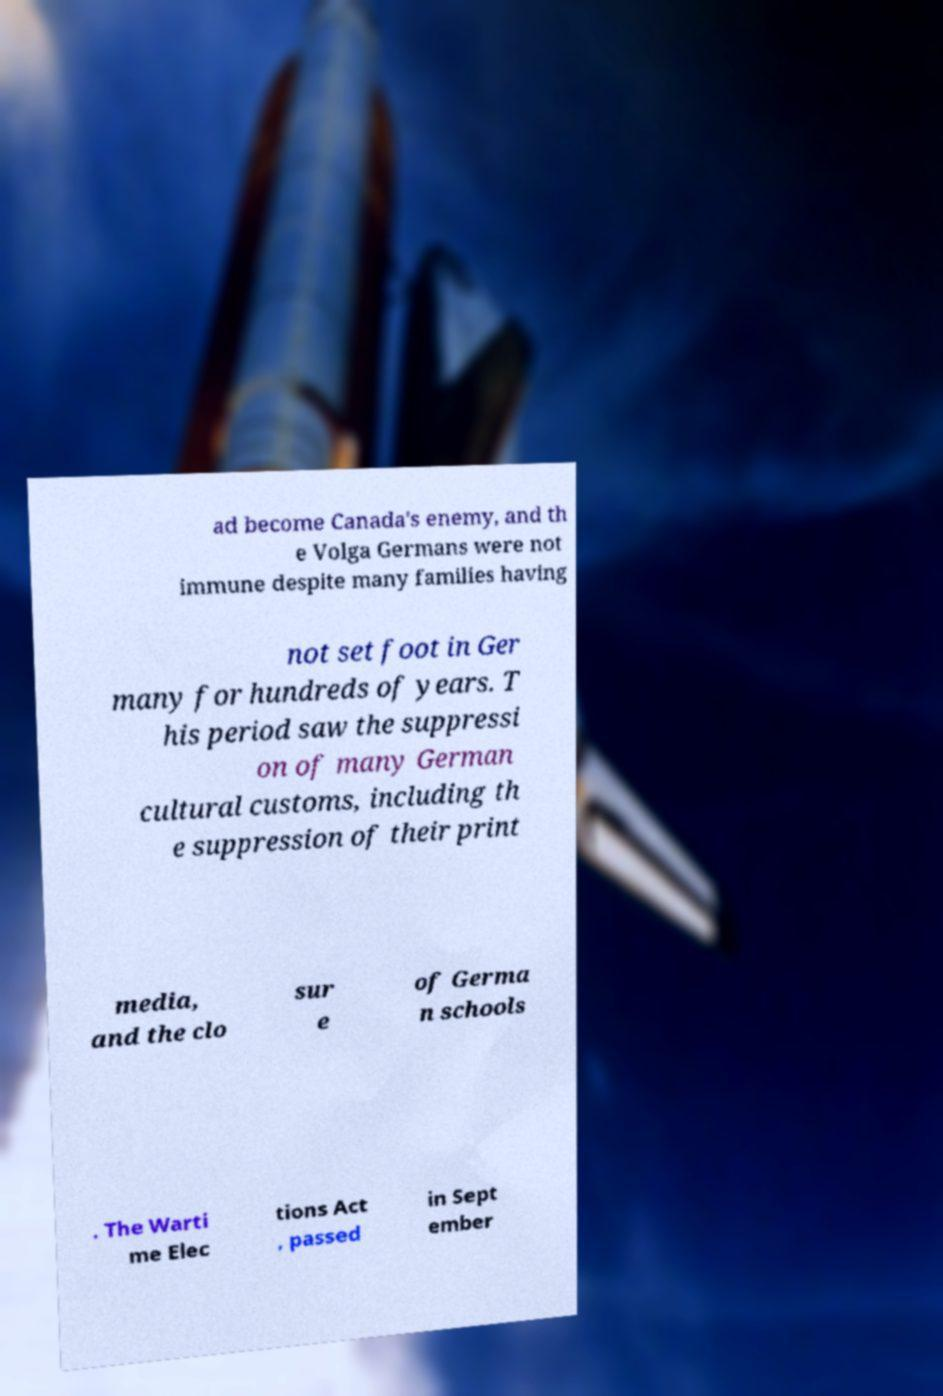Please read and relay the text visible in this image. What does it say? ad become Canada's enemy, and th e Volga Germans were not immune despite many families having not set foot in Ger many for hundreds of years. T his period saw the suppressi on of many German cultural customs, including th e suppression of their print media, and the clo sur e of Germa n schools . The Warti me Elec tions Act , passed in Sept ember 